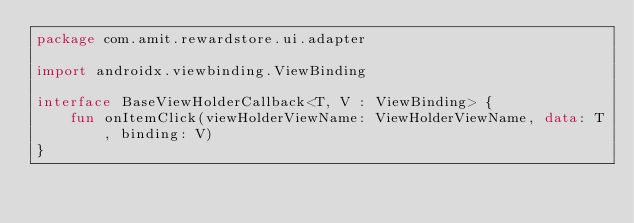<code> <loc_0><loc_0><loc_500><loc_500><_Kotlin_>package com.amit.rewardstore.ui.adapter

import androidx.viewbinding.ViewBinding

interface BaseViewHolderCallback<T, V : ViewBinding> {
    fun onItemClick(viewHolderViewName: ViewHolderViewName, data: T, binding: V)
}</code> 